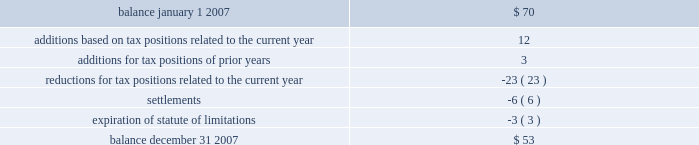Notes to consolidated financial statements note 11 .
Income taxes 2013 ( continued ) the federal income tax return for 2006 is subject to examination by the irs .
In addition for 2007 and 2008 , the irs has invited the company to participate in the compliance assurance process ( 201ccap 201d ) , which is a voluntary program for a limited number of large corporations .
Under cap , the irs conducts a real-time audit and works contemporaneously with the company to resolve any issues prior to the filing of the tax return .
The company has agreed to participate .
The company believes this approach should reduce tax-related uncertainties , if any .
The company and/or its subsidiaries also file income tax returns in various state , local and foreign jurisdictions .
These returns , with few exceptions , are no longer subject to examination by the various taxing authorities before as discussed in note 1 , the company adopted the provisions of fin no .
48 , 201caccounting for uncertainty in income taxes , 201d on january 1 , 2007 .
As a result of the implementation of fin no .
48 , the company recognized a decrease to beginning retained earnings on january 1 , 2007 of $ 37 million .
The total amount of unrecognized tax benefits as of the date of adoption was approximately $ 70 million .
Included in the balance at january 1 , 2007 , were $ 51 million of tax positions that if recognized would affect the effective tax rate .
A reconciliation of the beginning and ending amount of unrecognized tax benefits is as follows : ( in millions ) .
The company anticipates that it is reasonably possible that payments of approximately $ 2 million will be made primarily due to the conclusion of state income tax examinations within the next 12 months .
Additionally , certain state and foreign income tax returns will no longer be subject to examination and as a result , there is a reasonable possibility that the amount of unrecognized tax benefits will decrease by $ 7 million .
At december 31 , 2007 , there were $ 42 million of tax benefits that if recognized would affect the effective rate .
The company recognizes interest accrued related to : ( 1 ) unrecognized tax benefits in interest expense and ( 2 ) tax refund claims in other revenues on the consolidated statements of income .
The company recognizes penalties in income tax expense ( benefit ) on the consolidated statements of income .
During 2007 , the company recorded charges of approximately $ 4 million for interest expense and $ 2 million for penalties .
Provision has been made for the expected u.s .
Federal income tax liabilities applicable to undistributed earnings of subsidiaries , except for certain subsidiaries for which the company intends to invest the undistributed earnings indefinitely , or recover such undistributed earnings tax-free .
At december 31 , 2007 , the company has not provided deferred taxes of $ 126 million , if sold through a taxable sale , on $ 361 million of undistributed earnings related to a domestic affiliate .
The determination of the amount of the unrecognized deferred tax liability related to the undistributed earnings of foreign subsidiaries is not practicable .
In connection with a non-recurring distribution of $ 850 million to diamond offshore from a foreign subsidiary , a portion of which consisted of earnings of the subsidiary that had not previously been subjected to u.s .
Federal income tax , diamond offshore recognized $ 59 million of u.s .
Federal income tax expense as a result of the distribution .
It remains diamond offshore 2019s intention to indefinitely reinvest future earnings of the subsidiary to finance foreign activities .
Total income tax expense for the years ended december 31 , 2007 , 2006 and 2005 , was different than the amounts of $ 1601 million , $ 1557 million and $ 639 million , computed by applying the statutory u.s .
Federal income tax rate of 35% ( 35 % ) to income before income taxes and minority interest for each of the years. .
What is the ratio of the decrease in the retained earnings to the to the beginning amount of unrecognized tax benefits in 2007? 
Rationale: for every dollar of unrecognized tax benefits at january 1 , 2007 there was 0.53 reduction in retained earnings
Computations: (37 / 70)
Answer: 0.52857. 